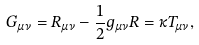<formula> <loc_0><loc_0><loc_500><loc_500>G _ { \mu \nu } = R _ { \mu \nu } - \frac { 1 } { 2 } g _ { \mu \nu } R = \kappa T _ { \mu \nu } ,</formula> 